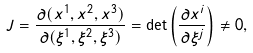Convert formula to latex. <formula><loc_0><loc_0><loc_500><loc_500>J = \frac { \partial ( x ^ { 1 } , x ^ { 2 } , x ^ { 3 } ) } { \partial ( \xi ^ { 1 } , \xi ^ { 2 } , \xi ^ { 3 } ) } = \det \left ( \frac { \partial x ^ { i } } { \partial \xi ^ { j } } \right ) \neq 0 ,</formula> 